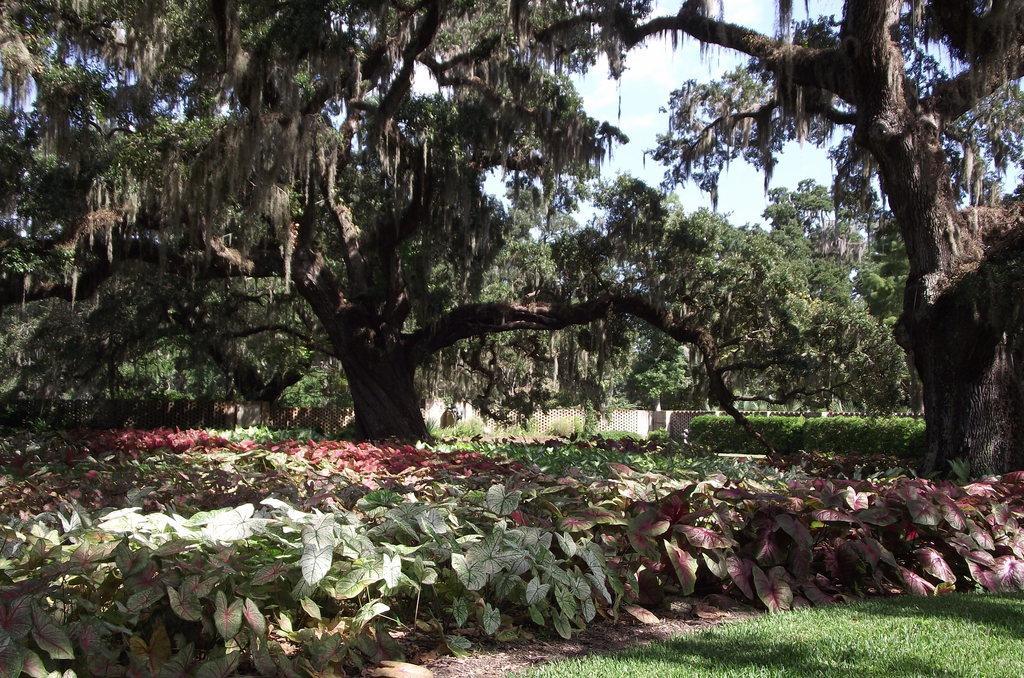Describe this image in one or two sentences. In this image we can see the grass, small plants, shrubs, trees, wooden fence and the sky in the background. 